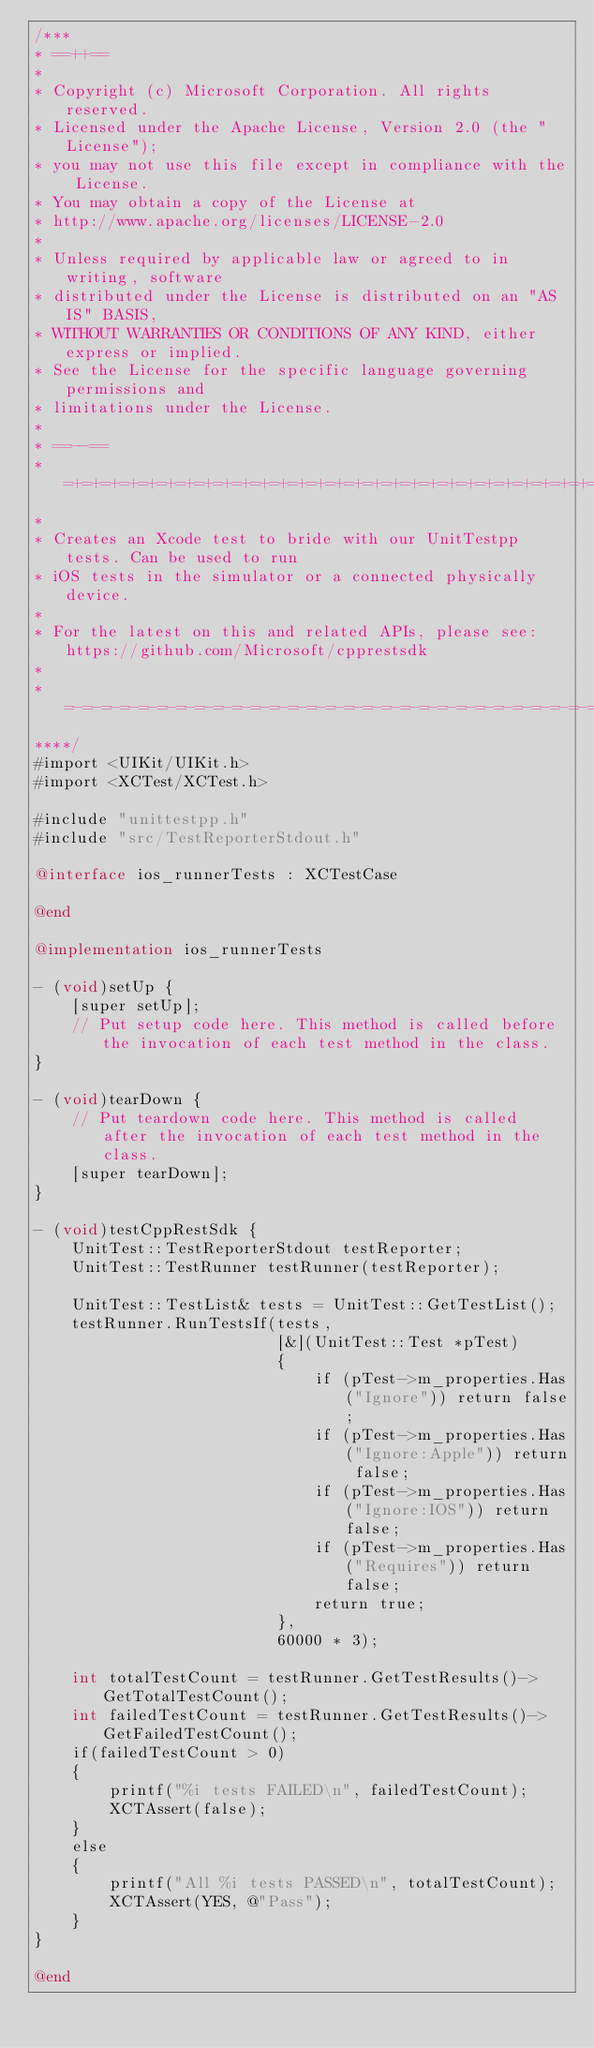<code> <loc_0><loc_0><loc_500><loc_500><_ObjectiveC_>/***
* ==++==
*
* Copyright (c) Microsoft Corporation. All rights reserved.
* Licensed under the Apache License, Version 2.0 (the "License");
* you may not use this file except in compliance with the License.
* You may obtain a copy of the License at
* http://www.apache.org/licenses/LICENSE-2.0
*
* Unless required by applicable law or agreed to in writing, software
* distributed under the License is distributed on an "AS IS" BASIS,
* WITHOUT WARRANTIES OR CONDITIONS OF ANY KIND, either express or implied.
* See the License for the specific language governing permissions and
* limitations under the License.
*
* ==--==
* =+=+=+=+=+=+=+=+=+=+=+=+=+=+=+=+=+=+=+=+=+=+=+=+=+=+=+=+=+=+=+=+=+=+=+=+=+=+=+=+=+=+=+=+=+=+=+=+=+=+=+=+=+=+=+=+
*
* Creates an Xcode test to bride with our UnitTestpp tests. Can be used to run
* iOS tests in the simulator or a connected physically device.
*
* For the latest on this and related APIs, please see: https://github.com/Microsoft/cpprestsdk
*
* =-=-=-=-=-=-=-=-=-=-=-=-=-=-=-=-=-=-=-=-=-=-=-=-=-=-=-=-=-=-=-=-=-=-=-=-=-=-=-=-=-=-=-=-=-=-=-=-=-=-=-=-=-=-=-=-
****/
#import <UIKit/UIKit.h>
#import <XCTest/XCTest.h>

#include "unittestpp.h"
#include "src/TestReporterStdout.h"

@interface ios_runnerTests : XCTestCase

@end

@implementation ios_runnerTests

- (void)setUp {
    [super setUp];
    // Put setup code here. This method is called before the invocation of each test method in the class.
}

- (void)tearDown {
    // Put teardown code here. This method is called after the invocation of each test method in the class.
    [super tearDown];
}

- (void)testCppRestSdk {
    UnitTest::TestReporterStdout testReporter;
    UnitTest::TestRunner testRunner(testReporter);
    
    UnitTest::TestList& tests = UnitTest::GetTestList();
    testRunner.RunTestsIf(tests,
                          [&](UnitTest::Test *pTest)
                          {
                              if (pTest->m_properties.Has("Ignore")) return false;
                              if (pTest->m_properties.Has("Ignore:Apple")) return false;
                              if (pTest->m_properties.Has("Ignore:IOS")) return false;
                              if (pTest->m_properties.Has("Requires")) return false;
                              return true;
                          },
                          60000 * 3);
    
    int totalTestCount = testRunner.GetTestResults()->GetTotalTestCount();
    int failedTestCount = testRunner.GetTestResults()->GetFailedTestCount();
    if(failedTestCount > 0)
    {
        printf("%i tests FAILED\n", failedTestCount);
        XCTAssert(false);
    }
    else
    {
        printf("All %i tests PASSED\n", totalTestCount);
        XCTAssert(YES, @"Pass");
    }
}

@end
</code> 